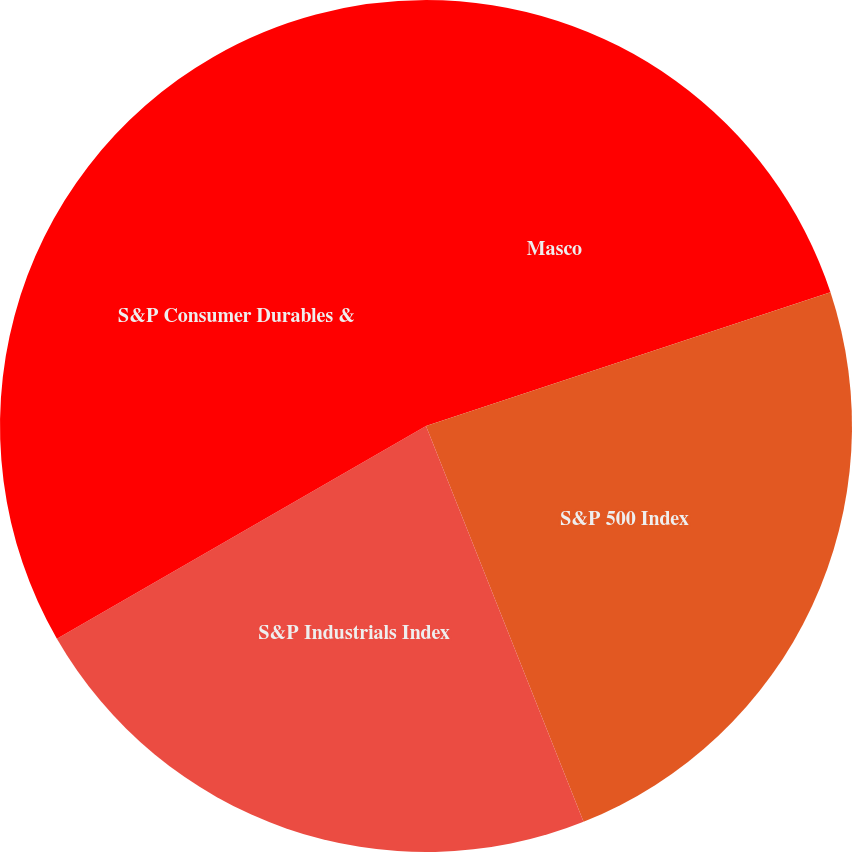Convert chart. <chart><loc_0><loc_0><loc_500><loc_500><pie_chart><fcel>Masco<fcel>S&P 500 Index<fcel>S&P Industrials Index<fcel>S&P Consumer Durables &<nl><fcel>19.92%<fcel>24.05%<fcel>22.71%<fcel>33.32%<nl></chart> 